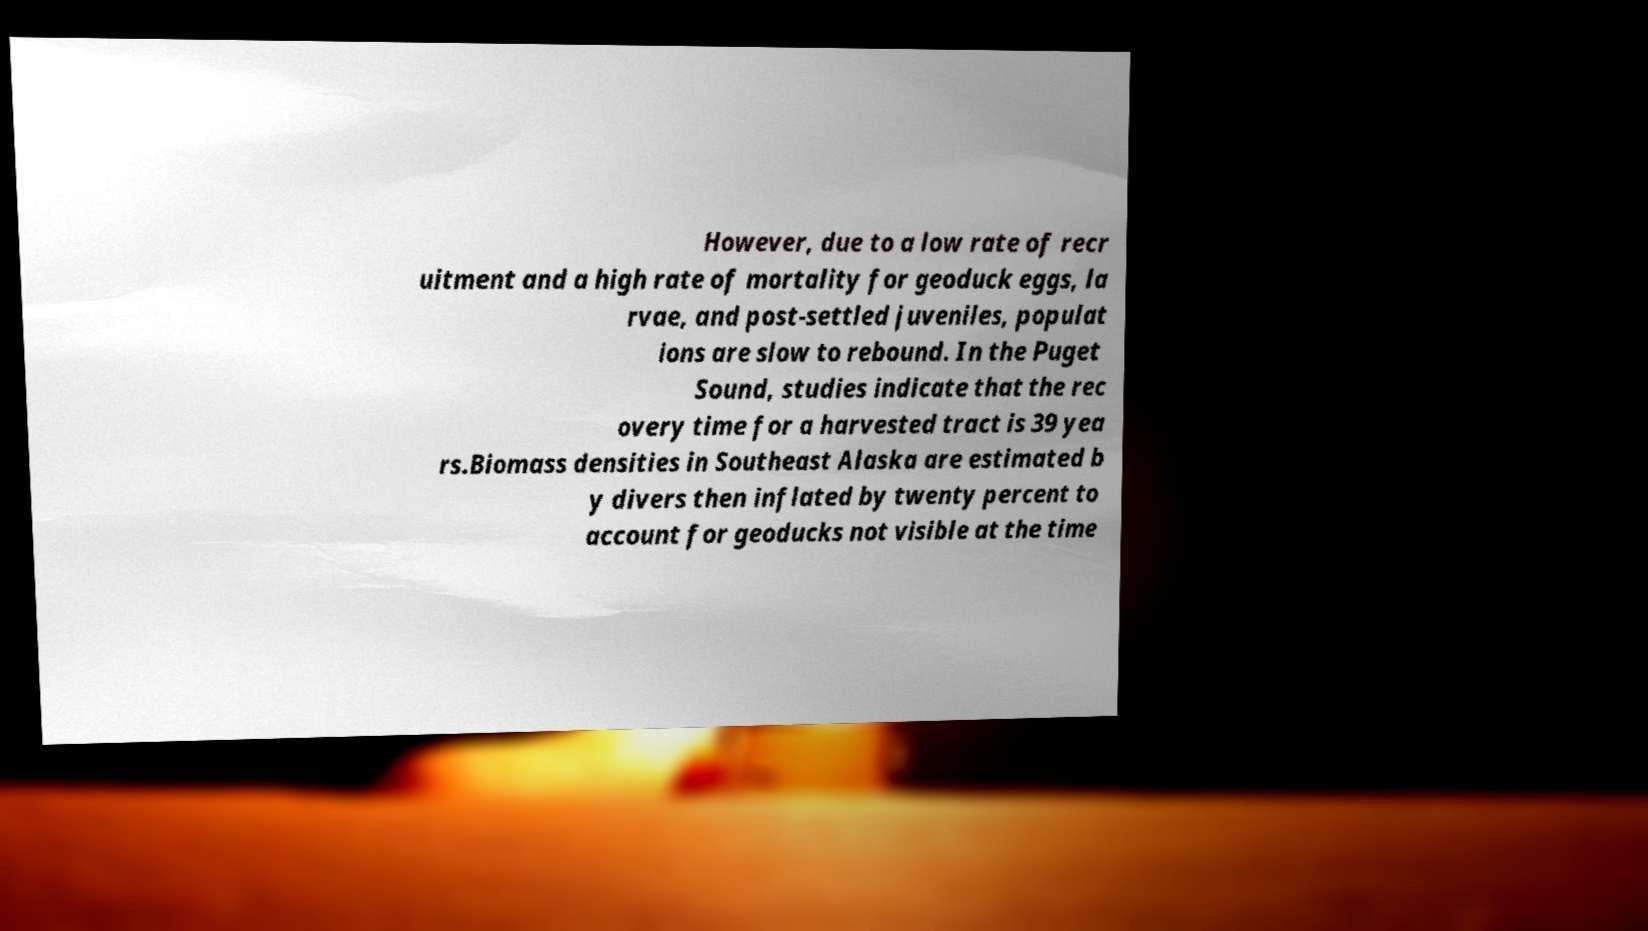Please identify and transcribe the text found in this image. However, due to a low rate of recr uitment and a high rate of mortality for geoduck eggs, la rvae, and post-settled juveniles, populat ions are slow to rebound. In the Puget Sound, studies indicate that the rec overy time for a harvested tract is 39 yea rs.Biomass densities in Southeast Alaska are estimated b y divers then inflated by twenty percent to account for geoducks not visible at the time 